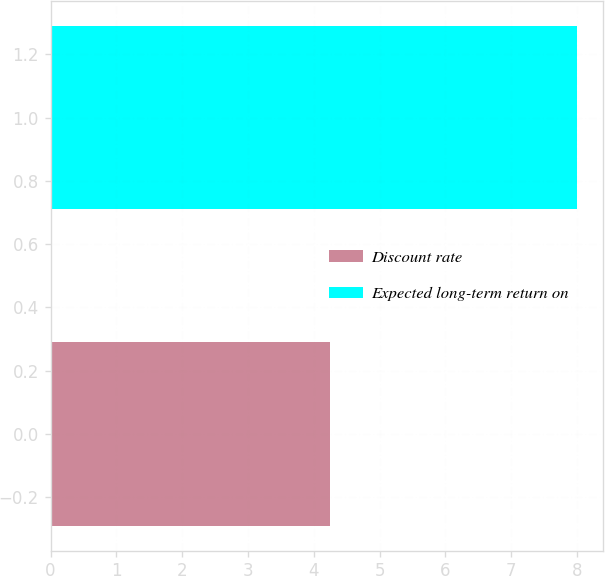Convert chart. <chart><loc_0><loc_0><loc_500><loc_500><bar_chart><fcel>Discount rate<fcel>Expected long-term return on<nl><fcel>4.25<fcel>8<nl></chart> 